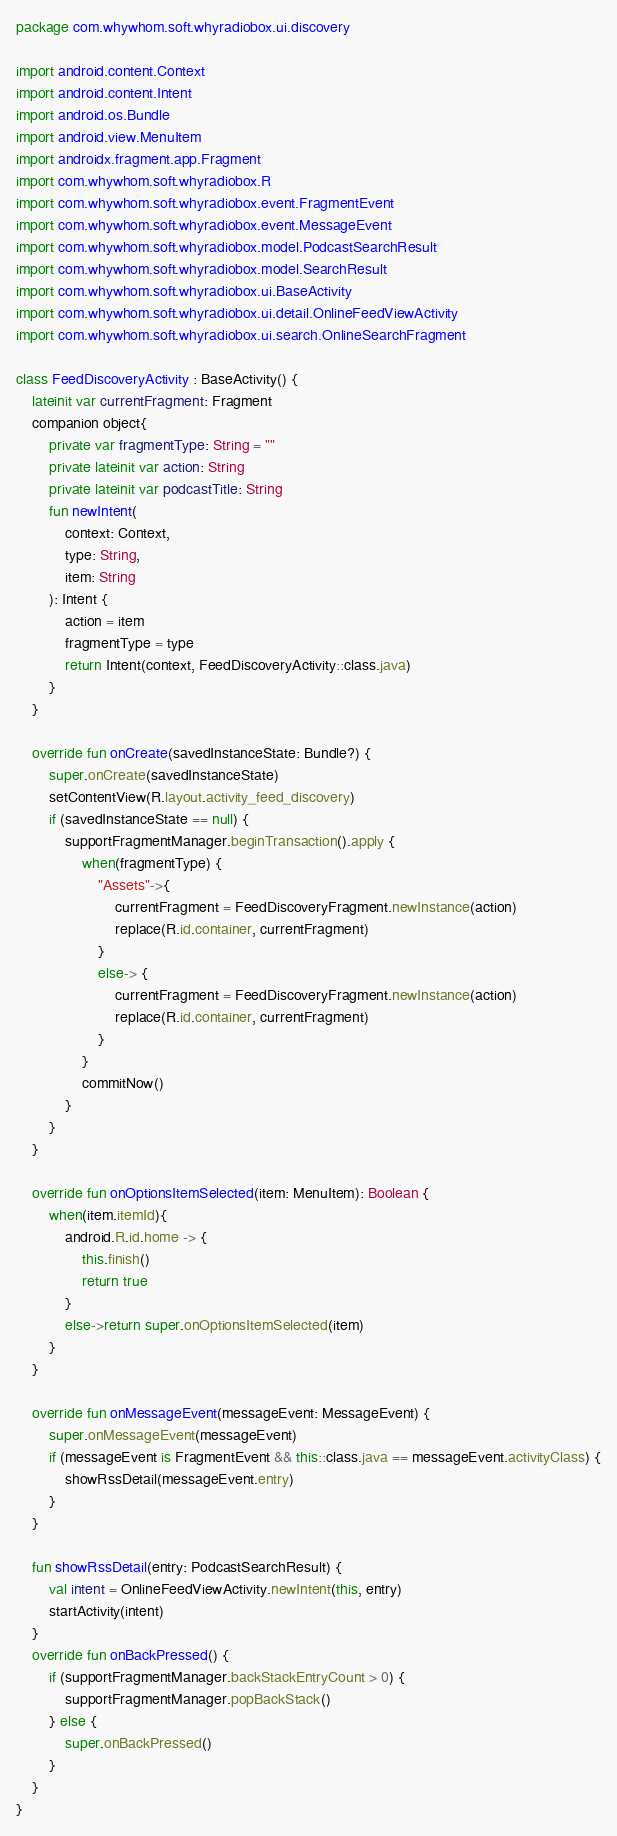Convert code to text. <code><loc_0><loc_0><loc_500><loc_500><_Kotlin_>package com.whywhom.soft.whyradiobox.ui.discovery

import android.content.Context
import android.content.Intent
import android.os.Bundle
import android.view.MenuItem
import androidx.fragment.app.Fragment
import com.whywhom.soft.whyradiobox.R
import com.whywhom.soft.whyradiobox.event.FragmentEvent
import com.whywhom.soft.whyradiobox.event.MessageEvent
import com.whywhom.soft.whyradiobox.model.PodcastSearchResult
import com.whywhom.soft.whyradiobox.model.SearchResult
import com.whywhom.soft.whyradiobox.ui.BaseActivity
import com.whywhom.soft.whyradiobox.ui.detail.OnlineFeedViewActivity
import com.whywhom.soft.whyradiobox.ui.search.OnlineSearchFragment

class FeedDiscoveryActivity : BaseActivity() {
    lateinit var currentFragment: Fragment
    companion object{
        private var fragmentType: String = ""
        private lateinit var action: String
        private lateinit var podcastTitle: String
        fun newIntent(
            context: Context,
            type: String,
            item: String
        ): Intent {
            action = item
            fragmentType = type
            return Intent(context, FeedDiscoveryActivity::class.java)
        }
    }

    override fun onCreate(savedInstanceState: Bundle?) {
        super.onCreate(savedInstanceState)
        setContentView(R.layout.activity_feed_discovery)
        if (savedInstanceState == null) {
            supportFragmentManager.beginTransaction().apply {
                when(fragmentType) {
                    "Assets"->{
                        currentFragment = FeedDiscoveryFragment.newInstance(action)
                        replace(R.id.container, currentFragment)
                    }
                    else-> {
                        currentFragment = FeedDiscoveryFragment.newInstance(action)
                        replace(R.id.container, currentFragment)
                    }
                }
                commitNow()
            }
        }
    }

    override fun onOptionsItemSelected(item: MenuItem): Boolean {
        when(item.itemId){
            android.R.id.home -> {
                this.finish()
                return true
            }
            else->return super.onOptionsItemSelected(item)
        }
    }

    override fun onMessageEvent(messageEvent: MessageEvent) {
        super.onMessageEvent(messageEvent)
        if (messageEvent is FragmentEvent && this::class.java == messageEvent.activityClass) {
            showRssDetail(messageEvent.entry)
        }
    }

    fun showRssDetail(entry: PodcastSearchResult) {
        val intent = OnlineFeedViewActivity.newIntent(this, entry)
        startActivity(intent)
    }
    override fun onBackPressed() {
        if (supportFragmentManager.backStackEntryCount > 0) {
            supportFragmentManager.popBackStack()
        } else {
            super.onBackPressed()
        }
    }
}
</code> 